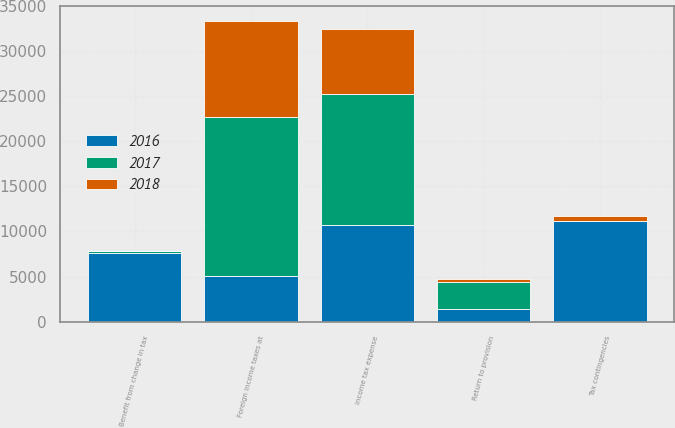Convert chart to OTSL. <chart><loc_0><loc_0><loc_500><loc_500><stacked_bar_chart><ecel><fcel>Foreign income taxes at<fcel>Tax contingencies<fcel>Return to provision<fcel>Benefit from change in tax<fcel>Income tax expense<nl><fcel>2017<fcel>17540<fcel>5<fcel>2961<fcel>117<fcel>14467<nl><fcel>2016<fcel>5089.5<fcel>11184<fcel>1397<fcel>7659<fcel>10742<nl><fcel>2018<fcel>10721<fcel>533<fcel>418<fcel>24<fcel>7218<nl></chart> 